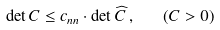<formula> <loc_0><loc_0><loc_500><loc_500>\det C \leq c _ { n n } \cdot \det \widehat { C } \, , \quad ( C > 0 )</formula> 